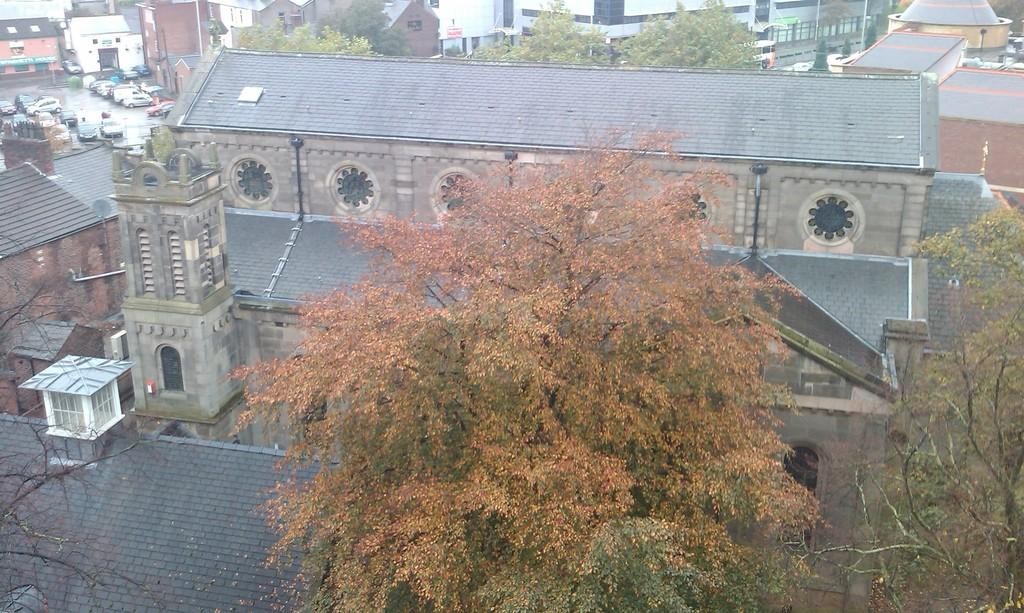What type of structures can be seen in the image? There are buildings in the image. What other natural elements are present in the image? There are trees in the image. What mode of transportation can be seen on the road in the image? There are vehicles on the road in the image. What type of card is being used to navigate the stars in the image? There is no card or stars present in the image; it features buildings, trees, and vehicles on the road. 